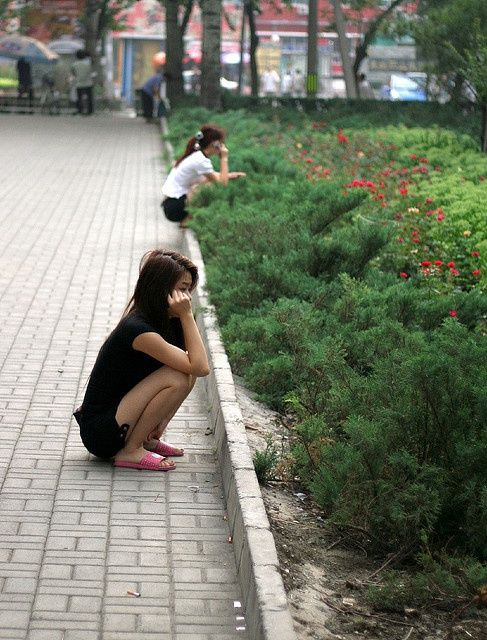Describe the objects in this image and their specific colors. I can see people in gray, black, and maroon tones, people in gray, white, black, and darkgray tones, umbrella in gray and darkgray tones, umbrella in gray, lavender, darkgray, lightpink, and pink tones, and people in gray and black tones in this image. 